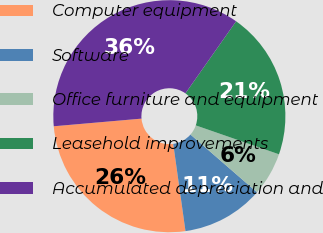Convert chart. <chart><loc_0><loc_0><loc_500><loc_500><pie_chart><fcel>Computer equipment<fcel>Software<fcel>Office furniture and equipment<fcel>Leasehold improvements<fcel>Accumulated depreciation and<nl><fcel>25.84%<fcel>11.41%<fcel>6.05%<fcel>20.57%<fcel>36.14%<nl></chart> 